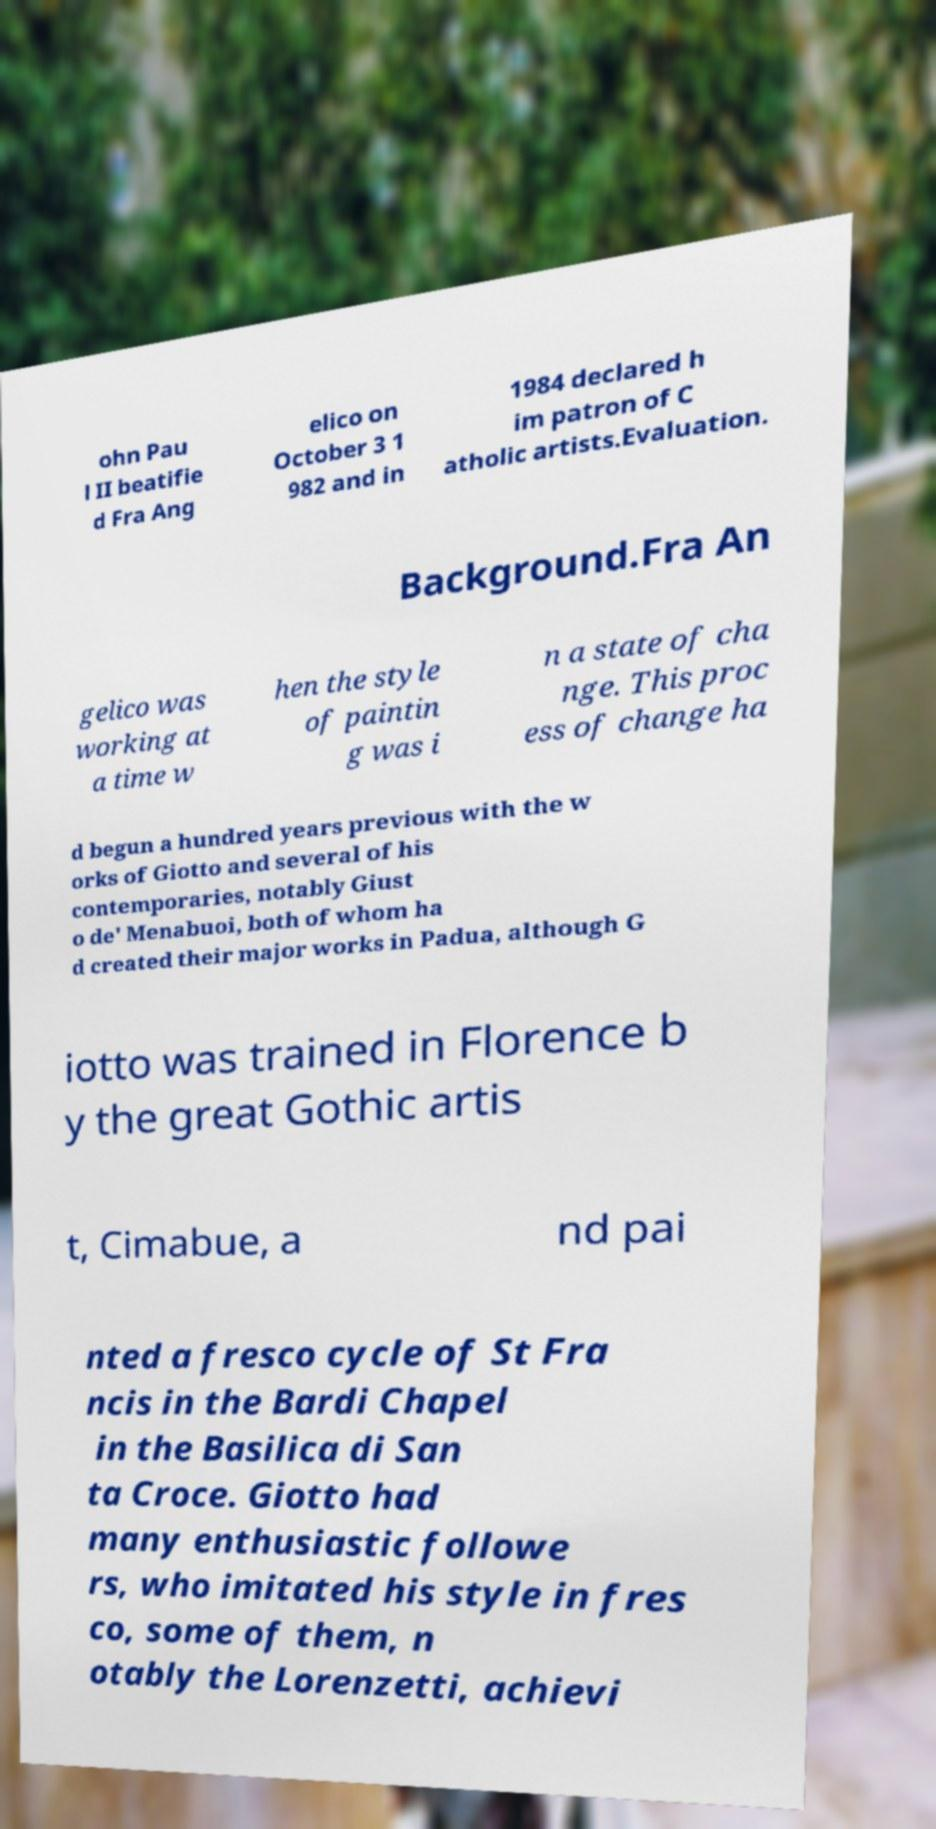What messages or text are displayed in this image? I need them in a readable, typed format. ohn Pau l II beatifie d Fra Ang elico on October 3 1 982 and in 1984 declared h im patron of C atholic artists.Evaluation. Background.Fra An gelico was working at a time w hen the style of paintin g was i n a state of cha nge. This proc ess of change ha d begun a hundred years previous with the w orks of Giotto and several of his contemporaries, notably Giust o de' Menabuoi, both of whom ha d created their major works in Padua, although G iotto was trained in Florence b y the great Gothic artis t, Cimabue, a nd pai nted a fresco cycle of St Fra ncis in the Bardi Chapel in the Basilica di San ta Croce. Giotto had many enthusiastic followe rs, who imitated his style in fres co, some of them, n otably the Lorenzetti, achievi 